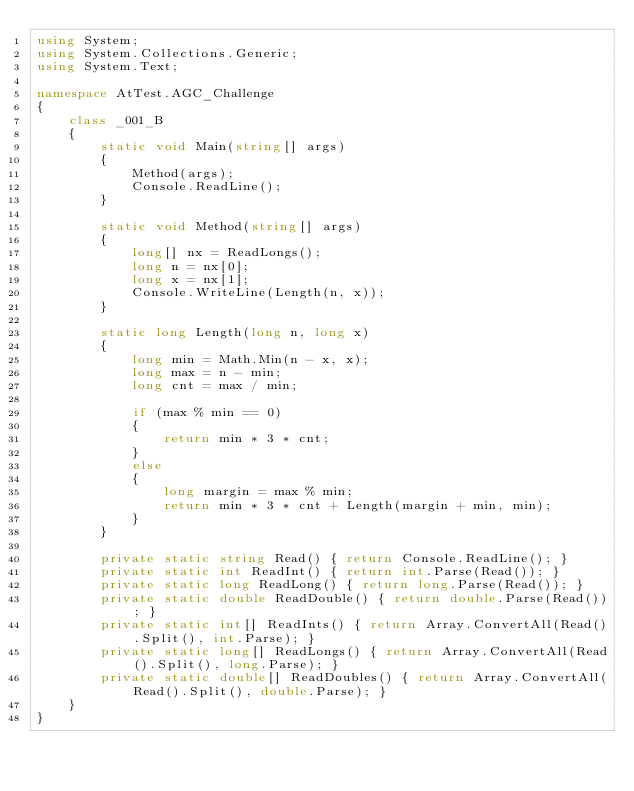Convert code to text. <code><loc_0><loc_0><loc_500><loc_500><_C#_>using System;
using System.Collections.Generic;
using System.Text;

namespace AtTest.AGC_Challenge
{
    class _001_B
    {
        static void Main(string[] args)
        {
            Method(args);
            Console.ReadLine();
        }

        static void Method(string[] args)
        {
            long[] nx = ReadLongs();
            long n = nx[0];
            long x = nx[1];
            Console.WriteLine(Length(n, x));
        }

        static long Length(long n, long x)
        {
            long min = Math.Min(n - x, x);
            long max = n - min;
            long cnt = max / min;

            if (max % min == 0)
            {
                return min * 3 * cnt;
            }
            else
            {
                long margin = max % min;
                return min * 3 * cnt + Length(margin + min, min);
            }
        }

        private static string Read() { return Console.ReadLine(); }
        private static int ReadInt() { return int.Parse(Read()); }
        private static long ReadLong() { return long.Parse(Read()); }
        private static double ReadDouble() { return double.Parse(Read()); }
        private static int[] ReadInts() { return Array.ConvertAll(Read().Split(), int.Parse); }
        private static long[] ReadLongs() { return Array.ConvertAll(Read().Split(), long.Parse); }
        private static double[] ReadDoubles() { return Array.ConvertAll(Read().Split(), double.Parse); }
    }
}
</code> 